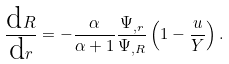Convert formula to latex. <formula><loc_0><loc_0><loc_500><loc_500>\frac { \text  dR}{\text  dr}= -\frac{\alpha}{\alpha+1}\frac{\Psi_{,r} } { \Psi _ { , R } } \left ( 1 - \frac { u } { Y } \right ) .</formula> 